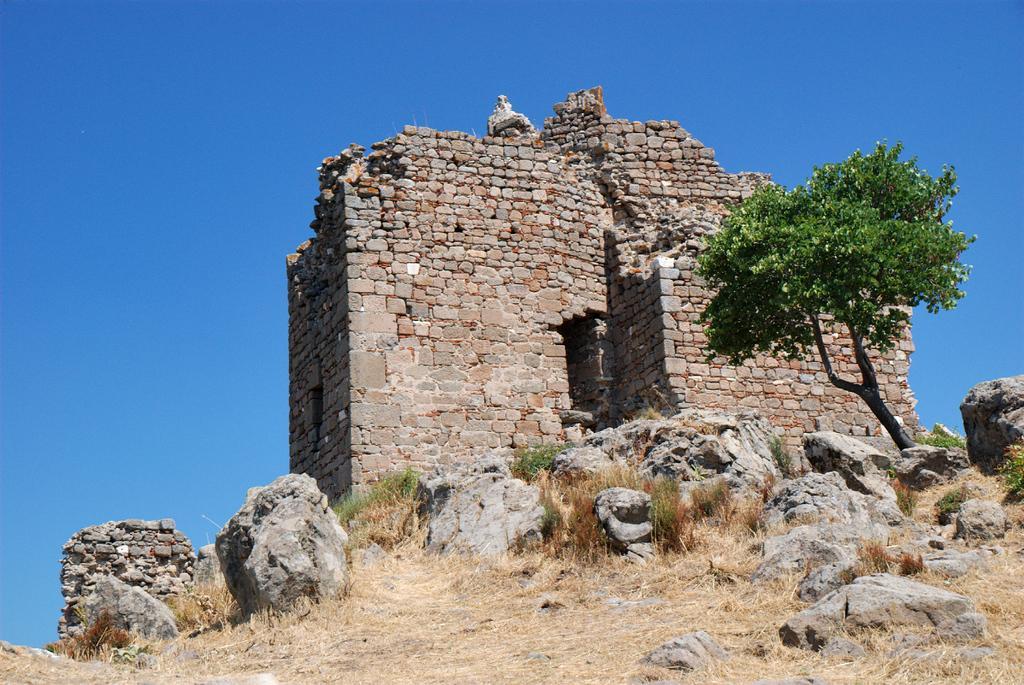Please provide a concise description of this image. There is a grassy land and rocks are present at the bottom of this image. We can see a monument and a tree in the middle of this image. The blue sky is in the background. 